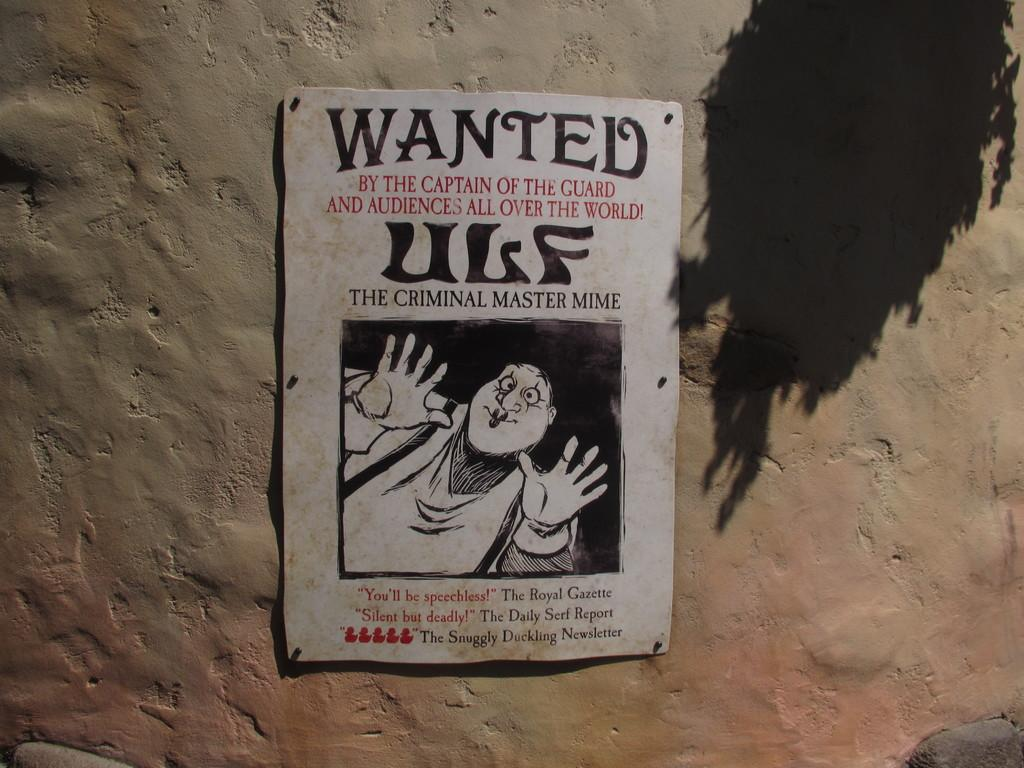What is the main object in the image? There is a board in the image. What is featured on the board? The board has a person depicted on it and text. Where is the board located? The board is on a wall. How does the pest affect the board in the image? There is no pest present in the image, so it cannot affect the board. 